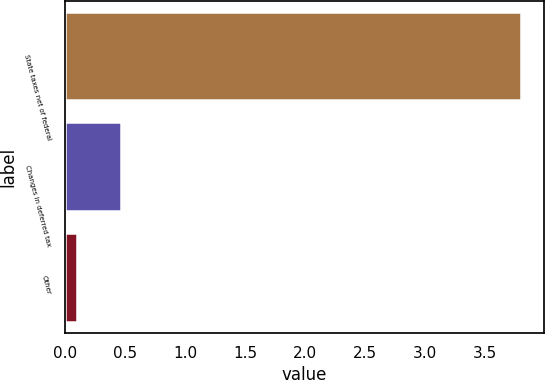Convert chart. <chart><loc_0><loc_0><loc_500><loc_500><bar_chart><fcel>State taxes net of federal<fcel>Changes in deferred tax<fcel>Other<nl><fcel>3.8<fcel>0.47<fcel>0.1<nl></chart> 